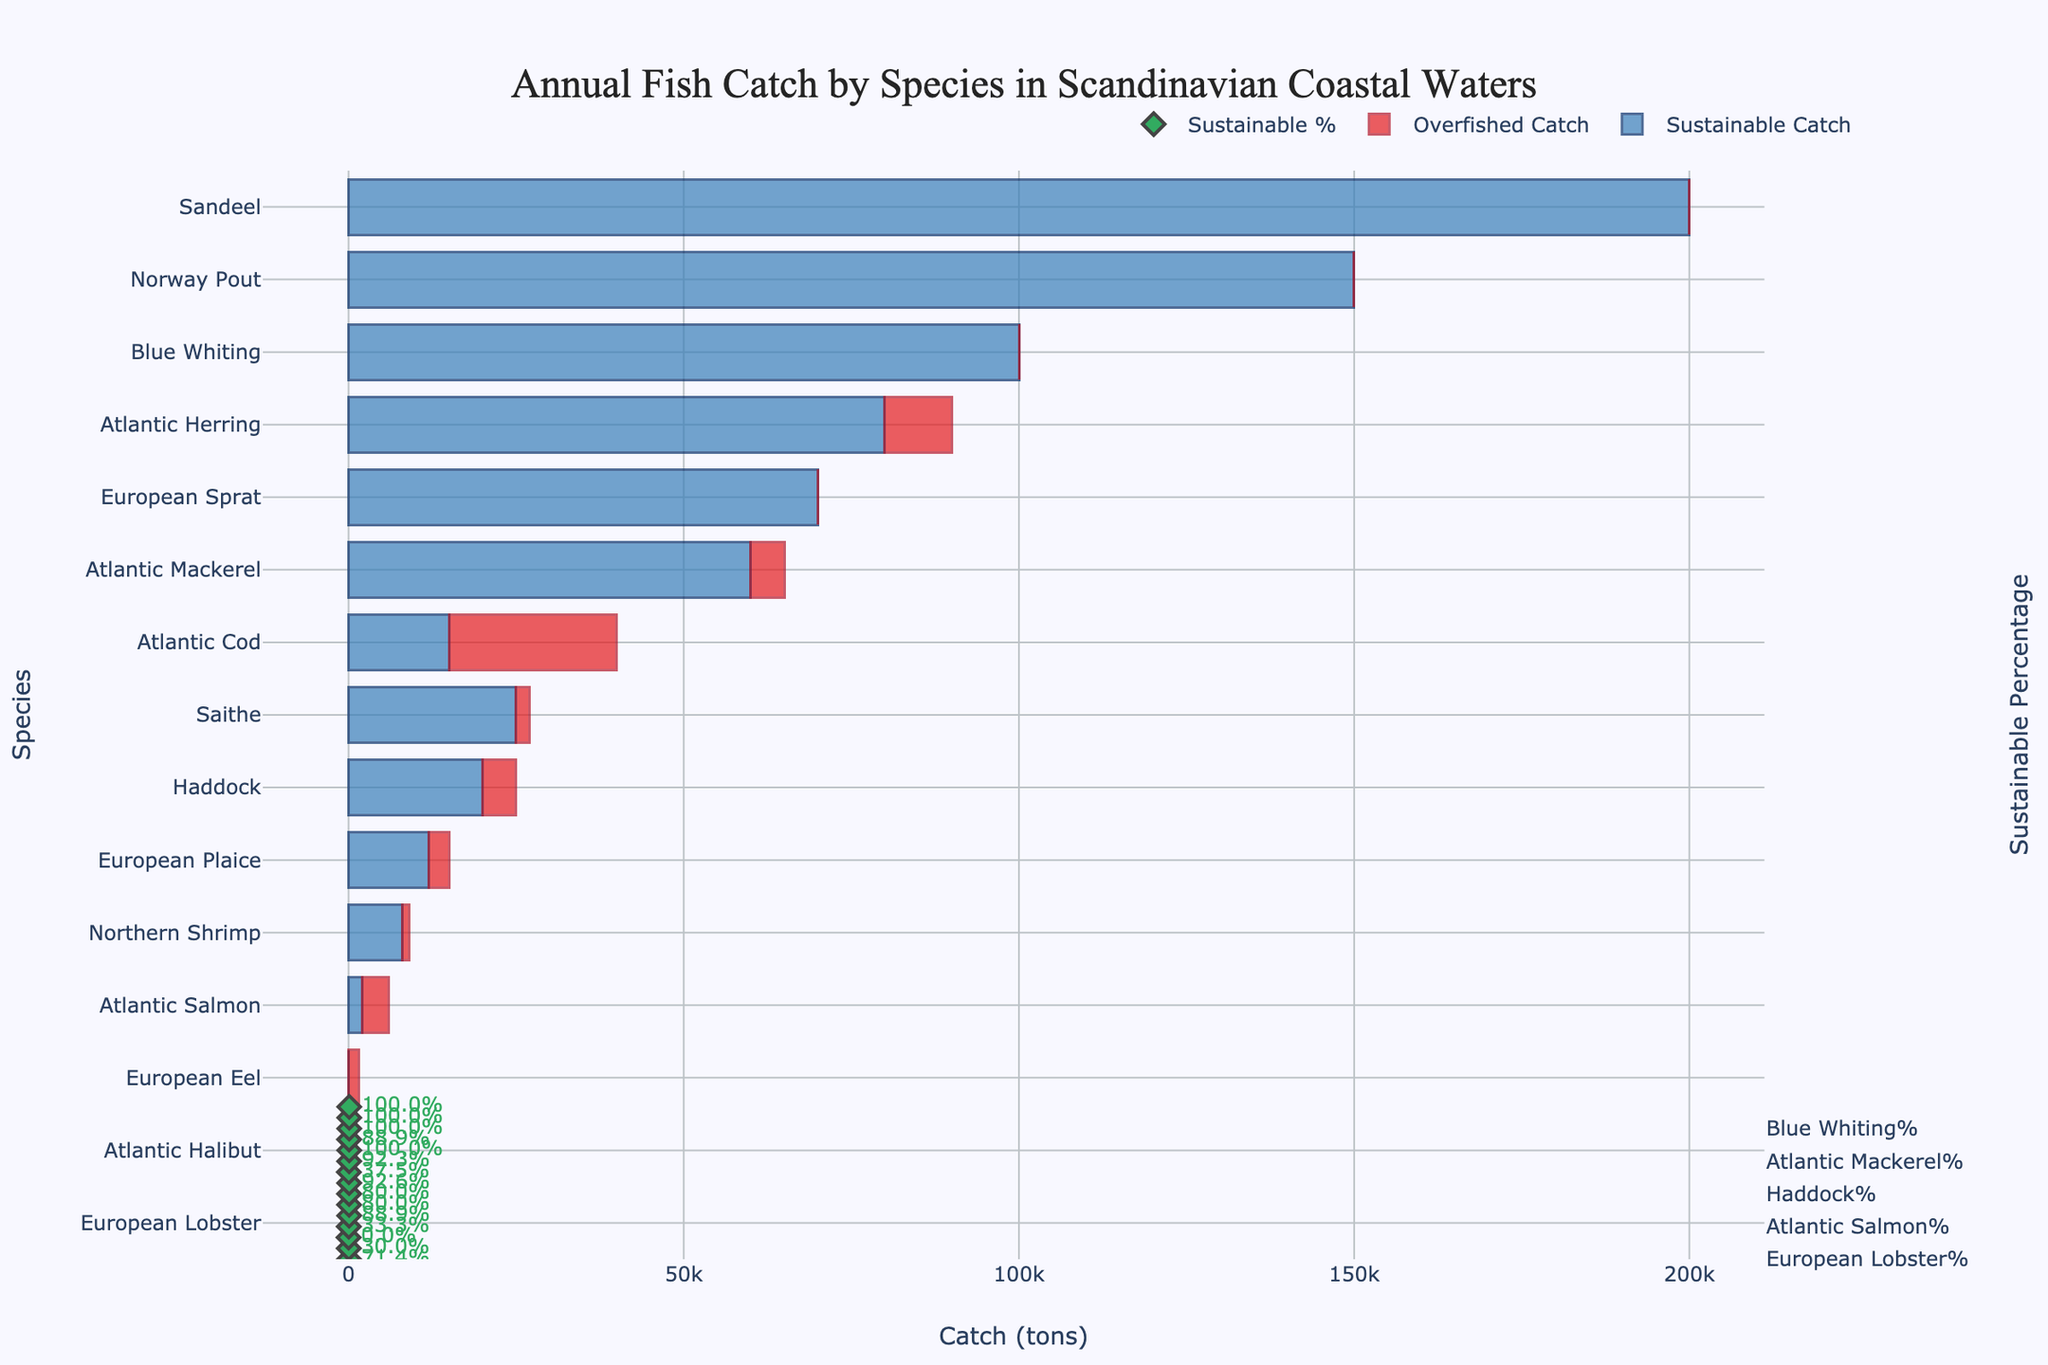Which species has the highest sustainable catch? By observing the bar chart, we can see that 'Sandeel' has the longest blue bar, which indicates the highest sustainable catch.
Answer: Sandeel Which species has an overfished catch but no sustainable catch? The red bar only (without any blue bar) represents overfished species. European Eel is the only species with an overfished catch but no sustainable catch.
Answer: European Eel What is the total catch (sum of sustainable and overfished) for Atlantic Cod? Add the sustainable catch and overfished catch for Atlantic Cod. It's 15000 (sustainable) + 25000 (overfished) = 40000 tons.
Answer: 40000 tons Which species has the smallest sustainable percentage? The percentage markers indicate the sustainable percentage. Atlantic Eel has no sustainable catch, so its percentage is 0%, which is the lowest.
Answer: European Eel Are there any species that are caught entirely sustainably (no overfished catch)? Look for species with only blue bars and no red bars. European Sprat, Norway Pout, Blue Whiting, and Sandeel fall into this category.
Answer: Yes, European Sprat, Norway Pout, Blue Whiting, Sandeel Which species seem most at risk due to overfishing relative to their total catch? We look at the percentages and the ratio of red bars to total catch. Atlantic Cod stands out with a significant overfished ratio relative to its total catch.
Answer: Atlantic Cod What is the combined total sustainable catch for Blue Whiting and Sandeel? Add the sustainable catches for both species. Blue Whiting: 100000 tons and Sandeel: 200000 tons. Combined total = 100000 + 200000 = 300000 tons.
Answer: 300000 tons Which species has a higher sustainable percentage: Atlantic Mackerel or Haddock? Compare the percentage markers for both species. Atlantic Mackerel has a sustainable catch percentage of around 92.3%, while Haddock has around 80%.
Answer: Atlantic Mackerel 